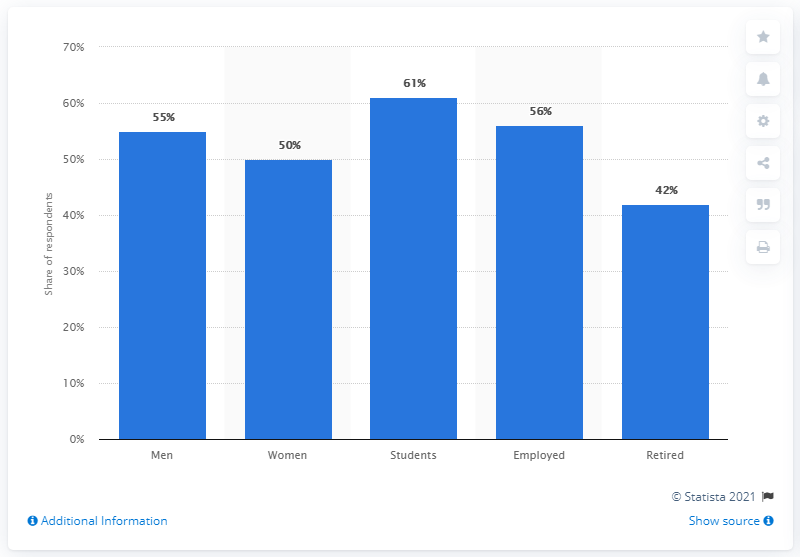Point out several critical features in this image. Which has the highest readership of any news paper or news service on the internet? Students. The difference between the highest and lowest readings of any newspaper or news service on the internet is 19... 